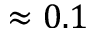Convert formula to latex. <formula><loc_0><loc_0><loc_500><loc_500>\approx 0 . 1</formula> 